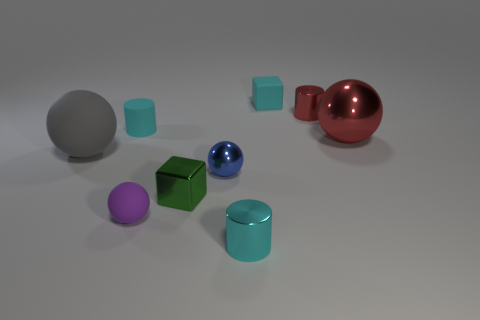Subtract all yellow cubes. How many cyan cylinders are left? 2 Subtract all tiny shiny cylinders. How many cylinders are left? 1 Subtract all red spheres. How many spheres are left? 3 Subtract all spheres. How many objects are left? 5 Subtract all blue spheres. Subtract all blue cylinders. How many spheres are left? 3 Add 8 tiny purple rubber balls. How many tiny purple rubber balls are left? 9 Add 2 large gray balls. How many large gray balls exist? 3 Subtract 1 red spheres. How many objects are left? 8 Subtract all small brown matte blocks. Subtract all cyan objects. How many objects are left? 6 